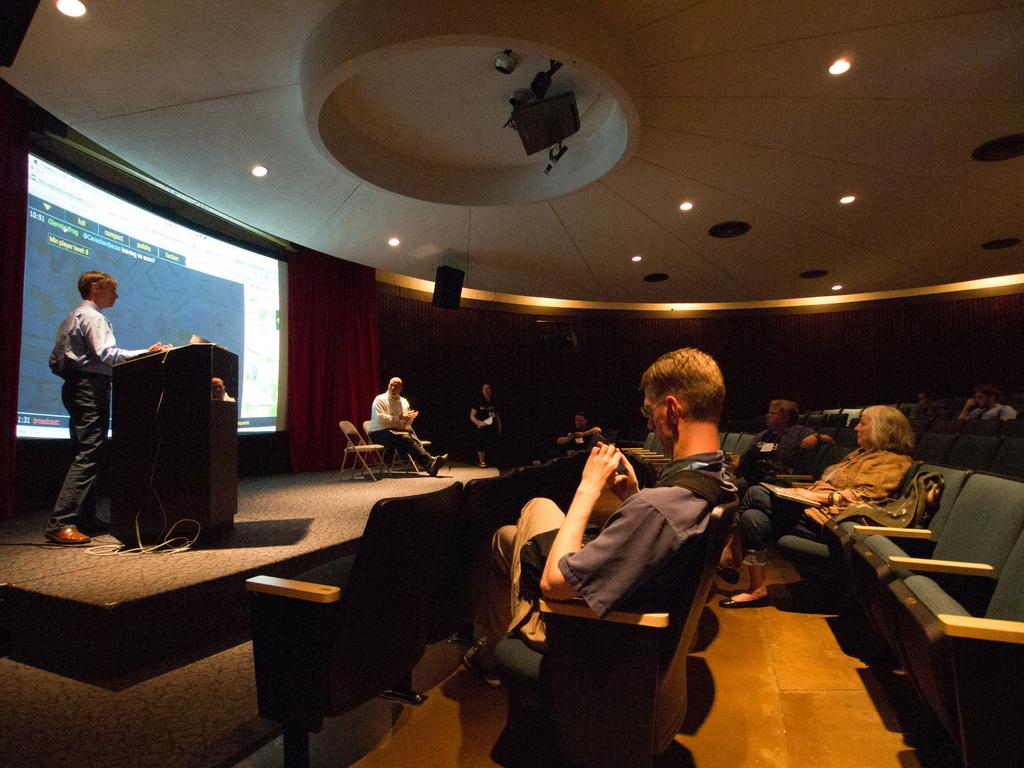What are the people in the image doing? The people in the image are sitting. What can be seen on the left side of the image? There is a man standing on the left side of the image. What is the man standing in front of? The man is standing before a podium. What is present in the image that displays information or visuals? There is a screen in the image. What type of window treatment is visible in the image? There are curtains in the image. What is visible at the top of the image that provides illumination? There are lights visible at the top of the image. What type of religious ceremony is taking place in the image? There is no indication of a religious ceremony in the image. How does the man stretch his arms before delivering his speech? The man is not stretching his arms in the image; he is standing before a podium. 